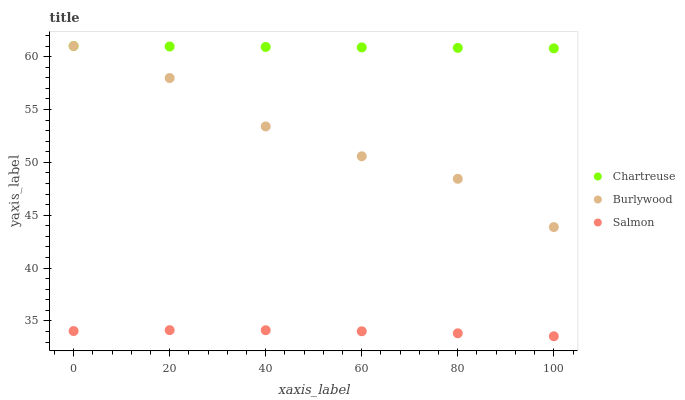Does Salmon have the minimum area under the curve?
Answer yes or no. Yes. Does Chartreuse have the maximum area under the curve?
Answer yes or no. Yes. Does Chartreuse have the minimum area under the curve?
Answer yes or no. No. Does Salmon have the maximum area under the curve?
Answer yes or no. No. Is Chartreuse the smoothest?
Answer yes or no. Yes. Is Burlywood the roughest?
Answer yes or no. Yes. Is Salmon the smoothest?
Answer yes or no. No. Is Salmon the roughest?
Answer yes or no. No. Does Salmon have the lowest value?
Answer yes or no. Yes. Does Chartreuse have the lowest value?
Answer yes or no. No. Does Chartreuse have the highest value?
Answer yes or no. Yes. Does Salmon have the highest value?
Answer yes or no. No. Is Salmon less than Chartreuse?
Answer yes or no. Yes. Is Burlywood greater than Salmon?
Answer yes or no. Yes. Does Burlywood intersect Chartreuse?
Answer yes or no. Yes. Is Burlywood less than Chartreuse?
Answer yes or no. No. Is Burlywood greater than Chartreuse?
Answer yes or no. No. Does Salmon intersect Chartreuse?
Answer yes or no. No. 